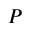Convert formula to latex. <formula><loc_0><loc_0><loc_500><loc_500>P</formula> 